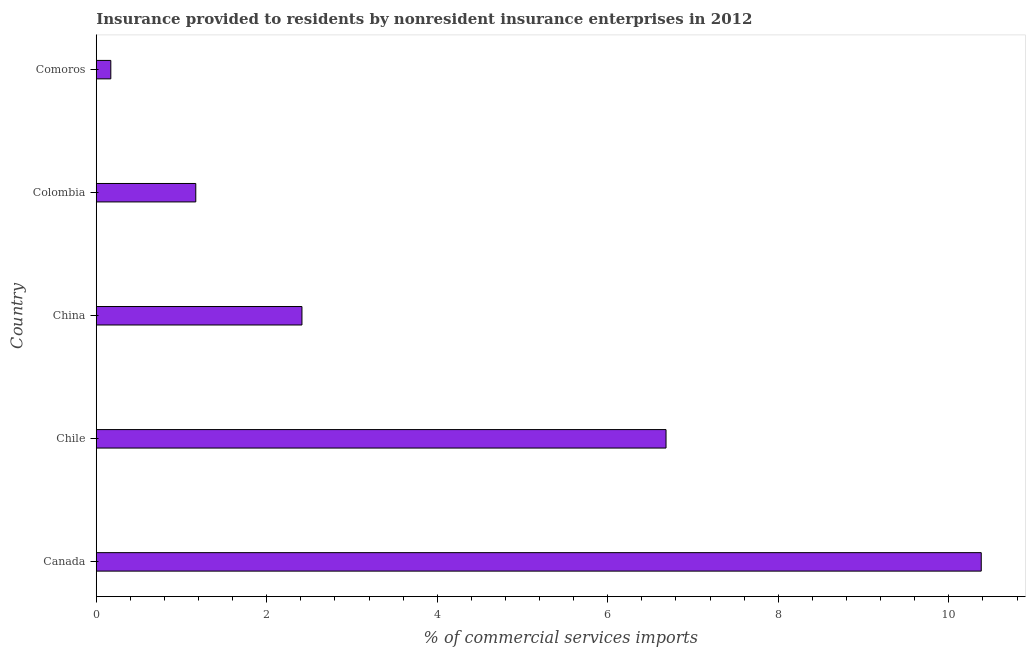Does the graph contain any zero values?
Offer a terse response. No. What is the title of the graph?
Your answer should be compact. Insurance provided to residents by nonresident insurance enterprises in 2012. What is the label or title of the X-axis?
Give a very brief answer. % of commercial services imports. What is the insurance provided by non-residents in Comoros?
Offer a terse response. 0.17. Across all countries, what is the maximum insurance provided by non-residents?
Your answer should be compact. 10.38. Across all countries, what is the minimum insurance provided by non-residents?
Keep it short and to the point. 0.17. In which country was the insurance provided by non-residents maximum?
Provide a short and direct response. Canada. In which country was the insurance provided by non-residents minimum?
Ensure brevity in your answer.  Comoros. What is the sum of the insurance provided by non-residents?
Make the answer very short. 20.81. What is the difference between the insurance provided by non-residents in Chile and China?
Offer a very short reply. 4.27. What is the average insurance provided by non-residents per country?
Your response must be concise. 4.16. What is the median insurance provided by non-residents?
Provide a short and direct response. 2.41. What is the ratio of the insurance provided by non-residents in Canada to that in Comoros?
Your answer should be very brief. 60.84. Is the insurance provided by non-residents in Canada less than that in Colombia?
Provide a short and direct response. No. What is the difference between the highest and the second highest insurance provided by non-residents?
Keep it short and to the point. 3.7. Is the sum of the insurance provided by non-residents in Colombia and Comoros greater than the maximum insurance provided by non-residents across all countries?
Ensure brevity in your answer.  No. What is the difference between the highest and the lowest insurance provided by non-residents?
Offer a terse response. 10.21. What is the % of commercial services imports in Canada?
Your answer should be very brief. 10.38. What is the % of commercial services imports in Chile?
Keep it short and to the point. 6.68. What is the % of commercial services imports in China?
Offer a terse response. 2.41. What is the % of commercial services imports of Colombia?
Give a very brief answer. 1.17. What is the % of commercial services imports of Comoros?
Offer a very short reply. 0.17. What is the difference between the % of commercial services imports in Canada and Chile?
Ensure brevity in your answer.  3.7. What is the difference between the % of commercial services imports in Canada and China?
Your answer should be very brief. 7.97. What is the difference between the % of commercial services imports in Canada and Colombia?
Offer a very short reply. 9.21. What is the difference between the % of commercial services imports in Canada and Comoros?
Offer a very short reply. 10.21. What is the difference between the % of commercial services imports in Chile and China?
Your answer should be compact. 4.27. What is the difference between the % of commercial services imports in Chile and Colombia?
Ensure brevity in your answer.  5.52. What is the difference between the % of commercial services imports in Chile and Comoros?
Your answer should be compact. 6.51. What is the difference between the % of commercial services imports in China and Colombia?
Your answer should be compact. 1.25. What is the difference between the % of commercial services imports in China and Comoros?
Make the answer very short. 2.24. What is the difference between the % of commercial services imports in Colombia and Comoros?
Make the answer very short. 1. What is the ratio of the % of commercial services imports in Canada to that in Chile?
Offer a very short reply. 1.55. What is the ratio of the % of commercial services imports in Canada to that in China?
Keep it short and to the point. 4.3. What is the ratio of the % of commercial services imports in Canada to that in Colombia?
Ensure brevity in your answer.  8.89. What is the ratio of the % of commercial services imports in Canada to that in Comoros?
Your answer should be compact. 60.84. What is the ratio of the % of commercial services imports in Chile to that in China?
Your response must be concise. 2.77. What is the ratio of the % of commercial services imports in Chile to that in Colombia?
Provide a succinct answer. 5.72. What is the ratio of the % of commercial services imports in Chile to that in Comoros?
Provide a succinct answer. 39.17. What is the ratio of the % of commercial services imports in China to that in Colombia?
Provide a succinct answer. 2.07. What is the ratio of the % of commercial services imports in China to that in Comoros?
Give a very brief answer. 14.14. What is the ratio of the % of commercial services imports in Colombia to that in Comoros?
Give a very brief answer. 6.84. 